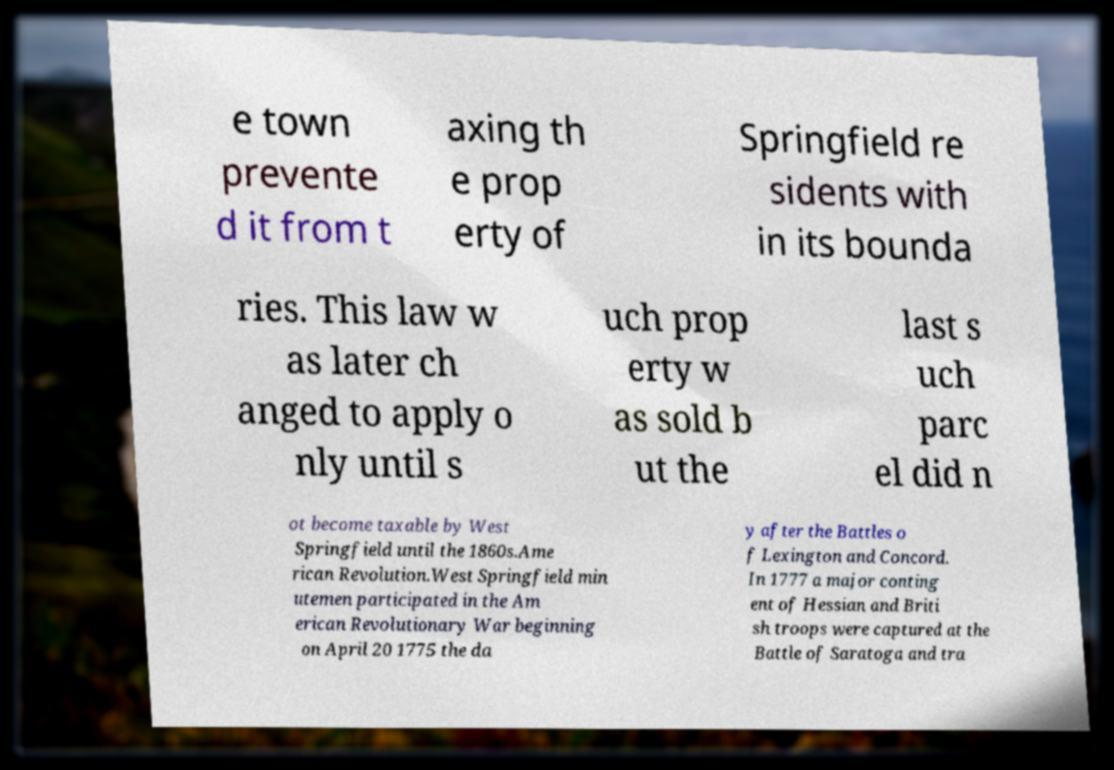Can you accurately transcribe the text from the provided image for me? e town prevente d it from t axing th e prop erty of Springfield re sidents with in its bounda ries. This law w as later ch anged to apply o nly until s uch prop erty w as sold b ut the last s uch parc el did n ot become taxable by West Springfield until the 1860s.Ame rican Revolution.West Springfield min utemen participated in the Am erican Revolutionary War beginning on April 20 1775 the da y after the Battles o f Lexington and Concord. In 1777 a major conting ent of Hessian and Briti sh troops were captured at the Battle of Saratoga and tra 